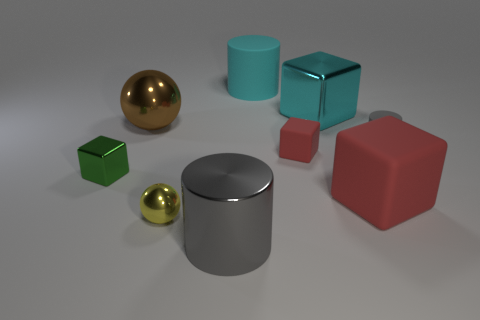Add 1 matte cylinders. How many objects exist? 10 Subtract all blocks. How many objects are left? 5 Add 3 balls. How many balls exist? 5 Subtract 0 brown cylinders. How many objects are left? 9 Subtract all cyan rubber cylinders. Subtract all spheres. How many objects are left? 6 Add 3 green shiny things. How many green shiny things are left? 4 